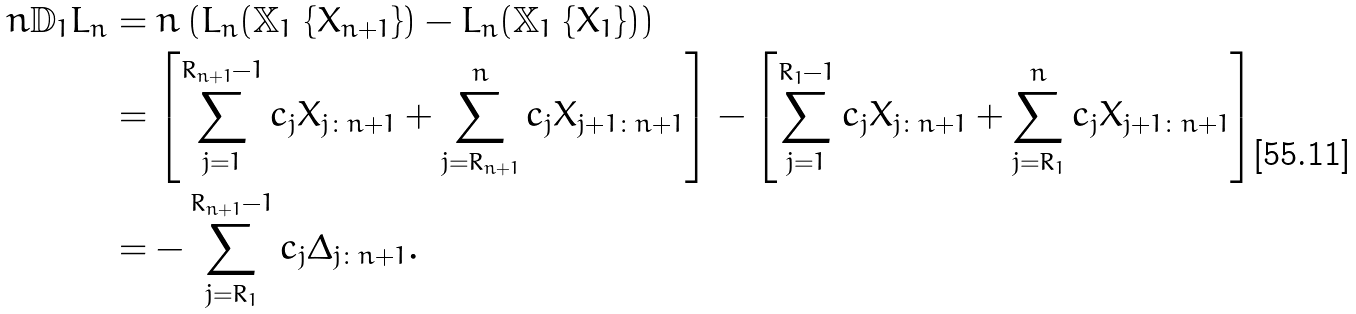<formula> <loc_0><loc_0><loc_500><loc_500>n \mathbb { D } _ { 1 } L _ { n } & = n \left ( L _ { n } ( \mathbb { X } _ { 1 } \ { \{ X _ { n + 1 } \} } ) - L _ { n } ( \mathbb { X } _ { 1 } \ { \{ X _ { 1 } \} } ) \right ) \\ & = \left [ \sum _ { j = 1 } ^ { R _ { n + 1 } - 1 } c _ { j } X _ { j \colon n + 1 } + \sum _ { j = R _ { n + 1 } } ^ { n } c _ { j } X _ { j + 1 \colon n + 1 } \right ] - \left [ \sum _ { j = 1 } ^ { R _ { 1 } - 1 } c _ { j } X _ { j \colon n + 1 } + \sum _ { j = R _ { 1 } } ^ { n } c _ { j } X _ { j + 1 \colon n + 1 } \right ] \\ & = - \sum _ { j = R _ { 1 } } ^ { R _ { n + 1 } - 1 } c _ { j } \Delta _ { j \colon n + 1 } .</formula> 